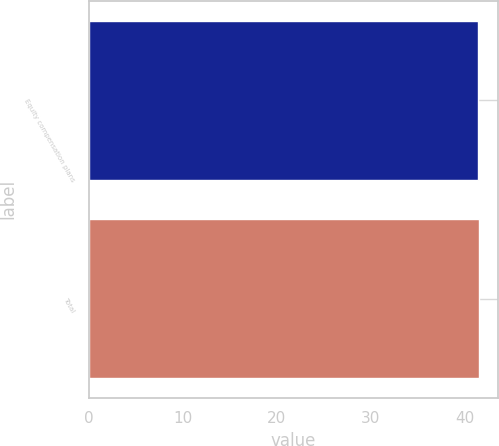Convert chart to OTSL. <chart><loc_0><loc_0><loc_500><loc_500><bar_chart><fcel>Equity compensation plans<fcel>Total<nl><fcel>41.41<fcel>41.51<nl></chart> 